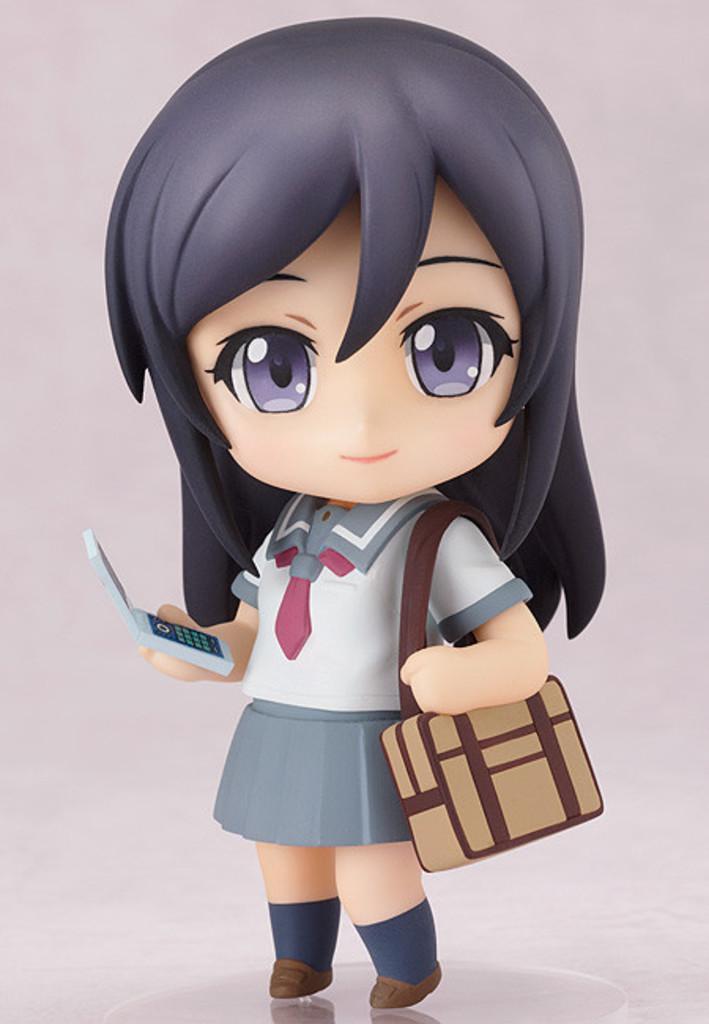In one or two sentences, can you explain what this image depicts? In this image, we can see depiction of a person on the pink background. This person is wearing a bag and holding a phone with her hand. 